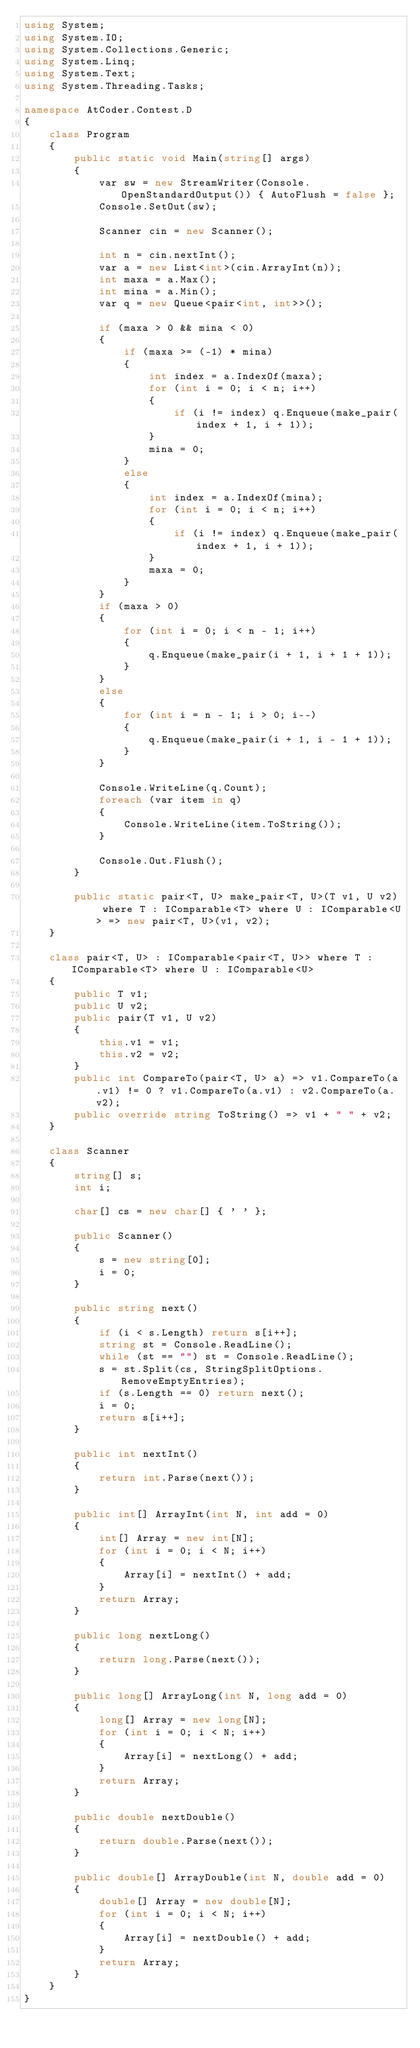Convert code to text. <code><loc_0><loc_0><loc_500><loc_500><_C#_>using System;
using System.IO;
using System.Collections.Generic;
using System.Linq;
using System.Text;
using System.Threading.Tasks;

namespace AtCoder.Contest.D
{
	class Program
	{
		public static void Main(string[] args)
		{
			var sw = new StreamWriter(Console.OpenStandardOutput()) { AutoFlush = false };
			Console.SetOut(sw);

			Scanner cin = new Scanner();

			int n = cin.nextInt();
			var a = new List<int>(cin.ArrayInt(n));
			int maxa = a.Max();
			int mina = a.Min();
			var q = new Queue<pair<int, int>>();

			if (maxa > 0 && mina < 0)
			{
				if (maxa >= (-1) * mina)
				{
					int index = a.IndexOf(maxa);
					for (int i = 0; i < n; i++)
					{
						if (i != index) q.Enqueue(make_pair(index + 1, i + 1));
					}
					mina = 0;
				}
				else
				{
					int index = a.IndexOf(mina);
					for (int i = 0; i < n; i++)
					{
						if (i != index) q.Enqueue(make_pair(index + 1, i + 1));
					}
					maxa = 0;
				}
			}
			if (maxa > 0)
			{
				for (int i = 0; i < n - 1; i++)
				{
					q.Enqueue(make_pair(i + 1, i + 1 + 1));
				}
			}
			else
			{
				for (int i = n - 1; i > 0; i--)
				{
					q.Enqueue(make_pair(i + 1, i - 1 + 1));
				}
			}

			Console.WriteLine(q.Count);
			foreach (var item in q)
			{
				Console.WriteLine(item.ToString());
			}

			Console.Out.Flush();
		}

		public static pair<T, U> make_pair<T, U>(T v1, U v2) where T : IComparable<T> where U : IComparable<U> => new pair<T, U>(v1, v2);
	}

	class pair<T, U> : IComparable<pair<T, U>> where T : IComparable<T> where U : IComparable<U>
	{
		public T v1;
		public U v2;
		public pair(T v1, U v2)
		{
			this.v1 = v1;
			this.v2 = v2;
		}
		public int CompareTo(pair<T, U> a) => v1.CompareTo(a.v1) != 0 ? v1.CompareTo(a.v1) : v2.CompareTo(a.v2);
		public override string ToString() => v1 + " " + v2;
	}

	class Scanner
	{
		string[] s;
		int i;

		char[] cs = new char[] { ' ' };

		public Scanner()
		{
			s = new string[0];
			i = 0;
		}

		public string next()
		{
			if (i < s.Length) return s[i++];
			string st = Console.ReadLine();
			while (st == "") st = Console.ReadLine();
			s = st.Split(cs, StringSplitOptions.RemoveEmptyEntries);
			if (s.Length == 0) return next();
			i = 0;
			return s[i++];
		}

		public int nextInt()
		{
			return int.Parse(next());
		}

		public int[] ArrayInt(int N, int add = 0)
		{
			int[] Array = new int[N];
			for (int i = 0; i < N; i++)
			{
				Array[i] = nextInt() + add;
			}
			return Array;
		}

		public long nextLong()
		{
			return long.Parse(next());
		}

		public long[] ArrayLong(int N, long add = 0)
		{
			long[] Array = new long[N];
			for (int i = 0; i < N; i++)
			{
				Array[i] = nextLong() + add;
			}
			return Array;
		}

		public double nextDouble()
		{
			return double.Parse(next());
		}

		public double[] ArrayDouble(int N, double add = 0)
		{
			double[] Array = new double[N];
			for (int i = 0; i < N; i++)
			{
				Array[i] = nextDouble() + add;
			}
			return Array;
		}
	}
}</code> 